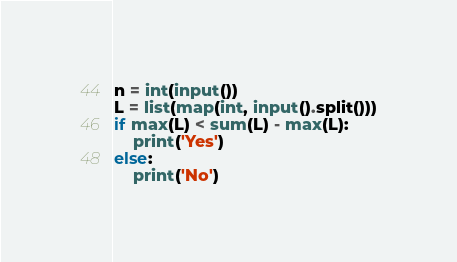Convert code to text. <code><loc_0><loc_0><loc_500><loc_500><_Python_>n = int(input())
L = list(map(int, input().split()))
if max(L) < sum(L) - max(L):
    print('Yes')
else:
    print('No')</code> 